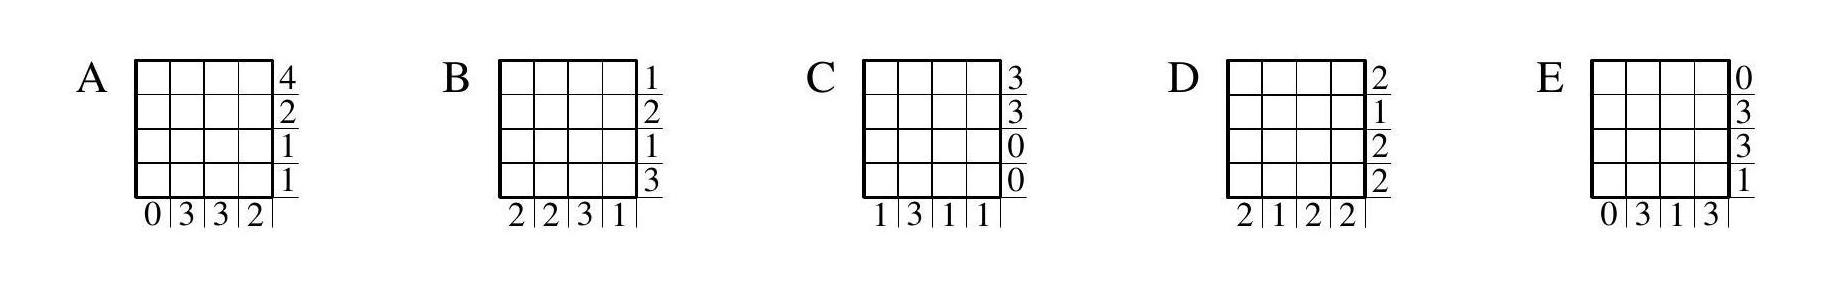Patricia painted some of the cells of a $4 \times 4$ grid. Carl counted how many red cells there were in each row and in each column and created a table to show his answers. Which of the following tables could Carl have created? To determine which table Carl could have created, we must ensure that the counts of red cells in each row match those listed for each corresponding row on the table, and the same for the columns. None of the tables provided perfectly matches an accurate distribution of red cells, as each table contains inconsistencies when cross-referencing the row and column totals. Therefore, none of the given choices A, B, C, D, or E are correct. This raises the possibility that Patricia may not have painted the cells in a way that is reflected in any of these options, or there could have been an error in Carl's counting. 